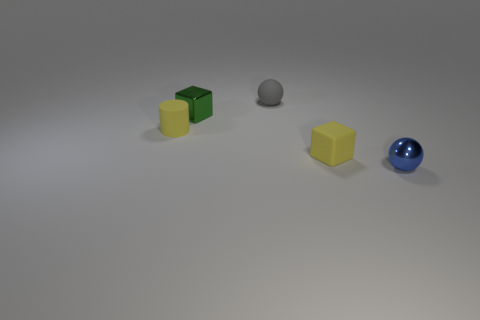Add 4 big blue rubber blocks. How many objects exist? 9 Subtract all cylinders. How many objects are left? 4 Subtract 0 cyan balls. How many objects are left? 5 Subtract all tiny gray blocks. Subtract all tiny yellow matte objects. How many objects are left? 3 Add 5 small green metallic cubes. How many small green metallic cubes are left? 6 Add 5 tiny yellow matte cylinders. How many tiny yellow matte cylinders exist? 6 